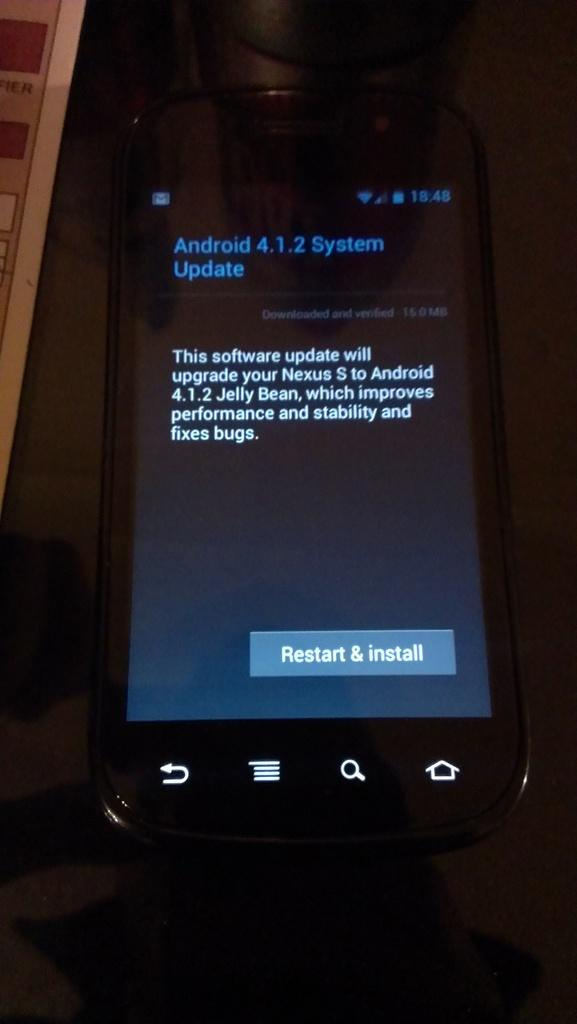<image>
Give a short and clear explanation of the subsequent image. a cell phone displaying a button for restart and install on the bottom 